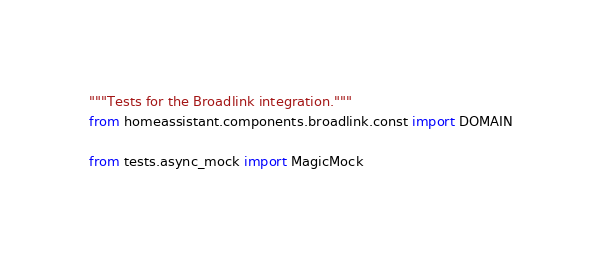Convert code to text. <code><loc_0><loc_0><loc_500><loc_500><_Python_>"""Tests for the Broadlink integration."""
from homeassistant.components.broadlink.const import DOMAIN

from tests.async_mock import MagicMock</code> 